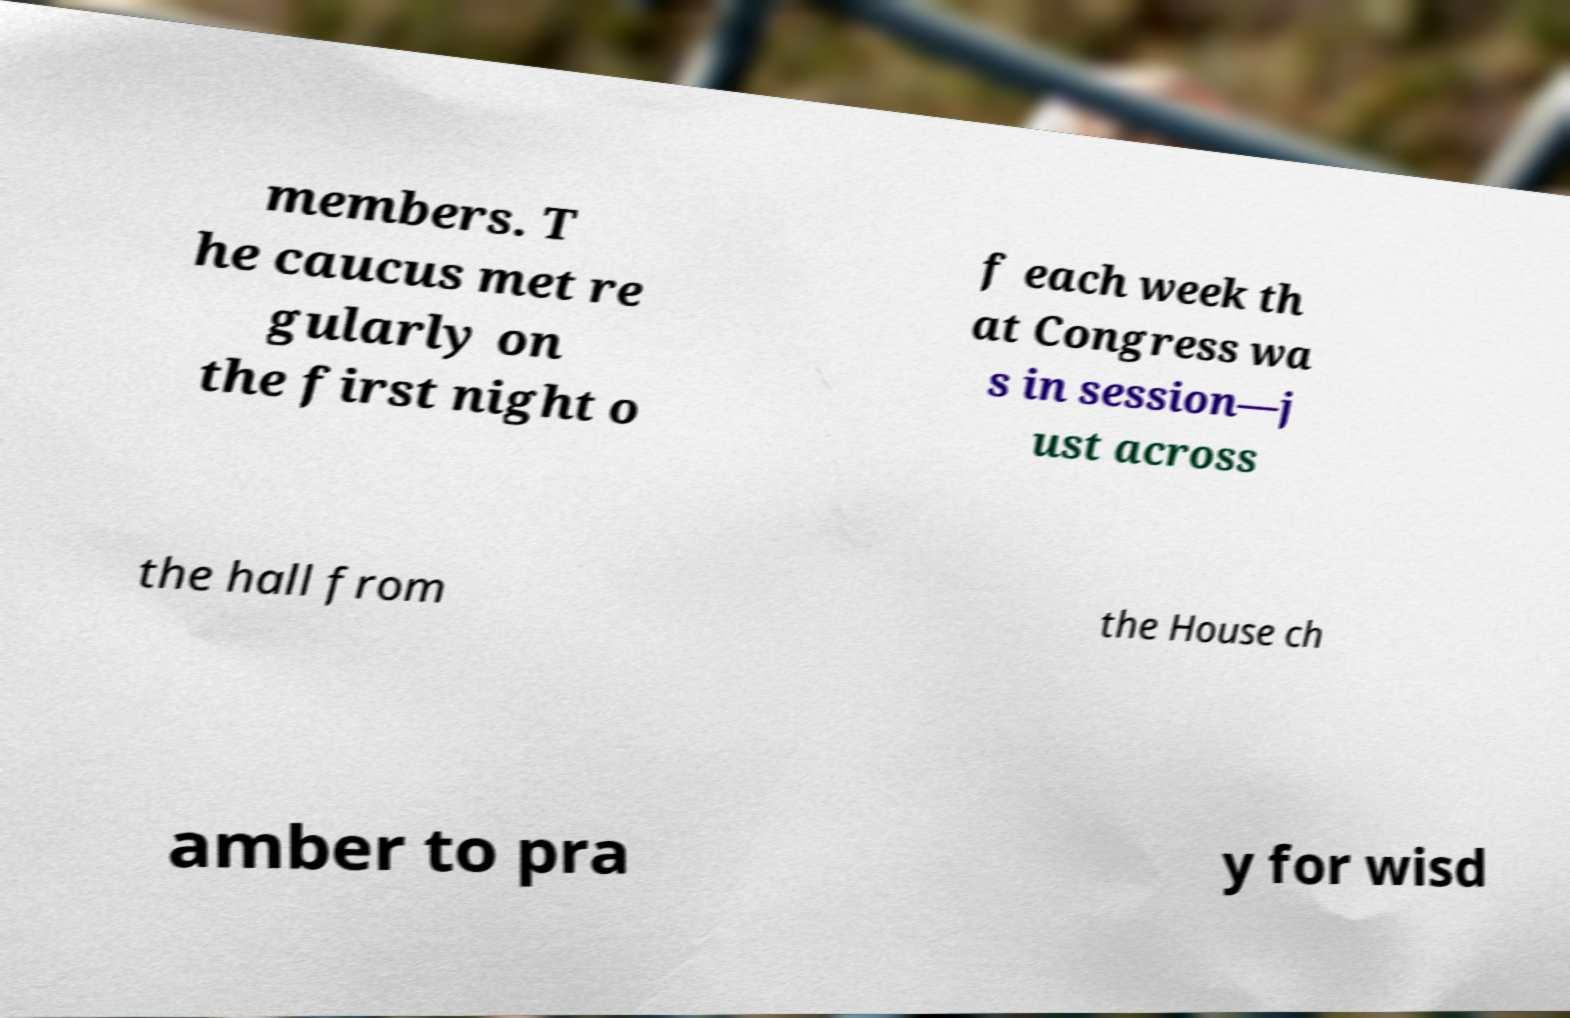Could you extract and type out the text from this image? members. T he caucus met re gularly on the first night o f each week th at Congress wa s in session—j ust across the hall from the House ch amber to pra y for wisd 